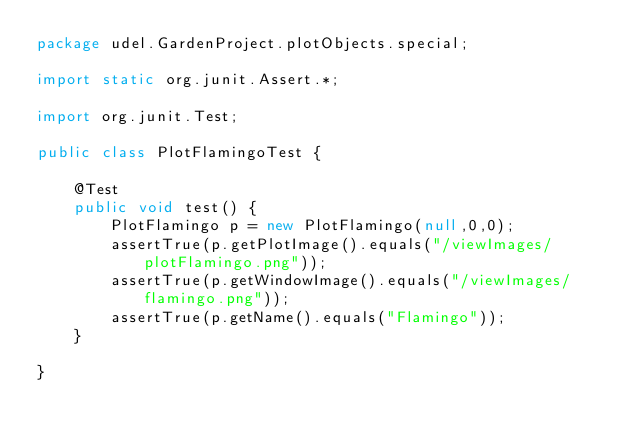Convert code to text. <code><loc_0><loc_0><loc_500><loc_500><_Java_>package udel.GardenProject.plotObjects.special;

import static org.junit.Assert.*;

import org.junit.Test;

public class PlotFlamingoTest {

	@Test
	public void test() {
		PlotFlamingo p = new PlotFlamingo(null,0,0);
		assertTrue(p.getPlotImage().equals("/viewImages/plotFlamingo.png"));
		assertTrue(p.getWindowImage().equals("/viewImages/flamingo.png"));
		assertTrue(p.getName().equals("Flamingo"));
	}

}
</code> 